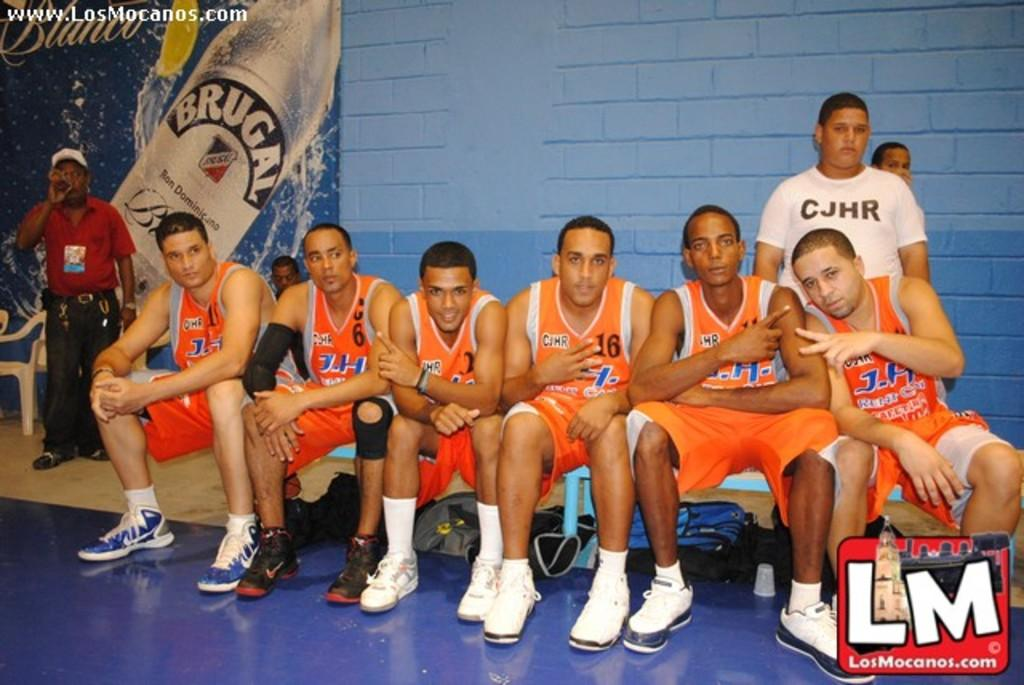Provide a one-sentence caption for the provided image. The J.H. team sits together on a bench. 